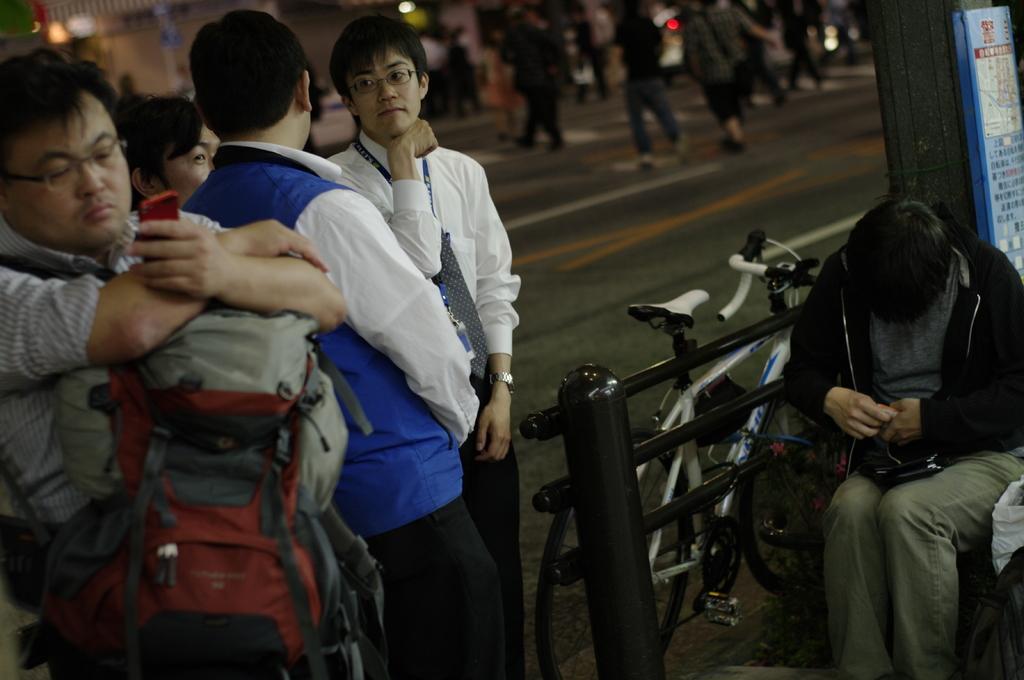Can you describe this image briefly? This man is holding a mobile and wire bag. Another man is sitting and holding an object. Backside of this man there is a board. Beside this fence there is a bicycle. Here we can see people. 